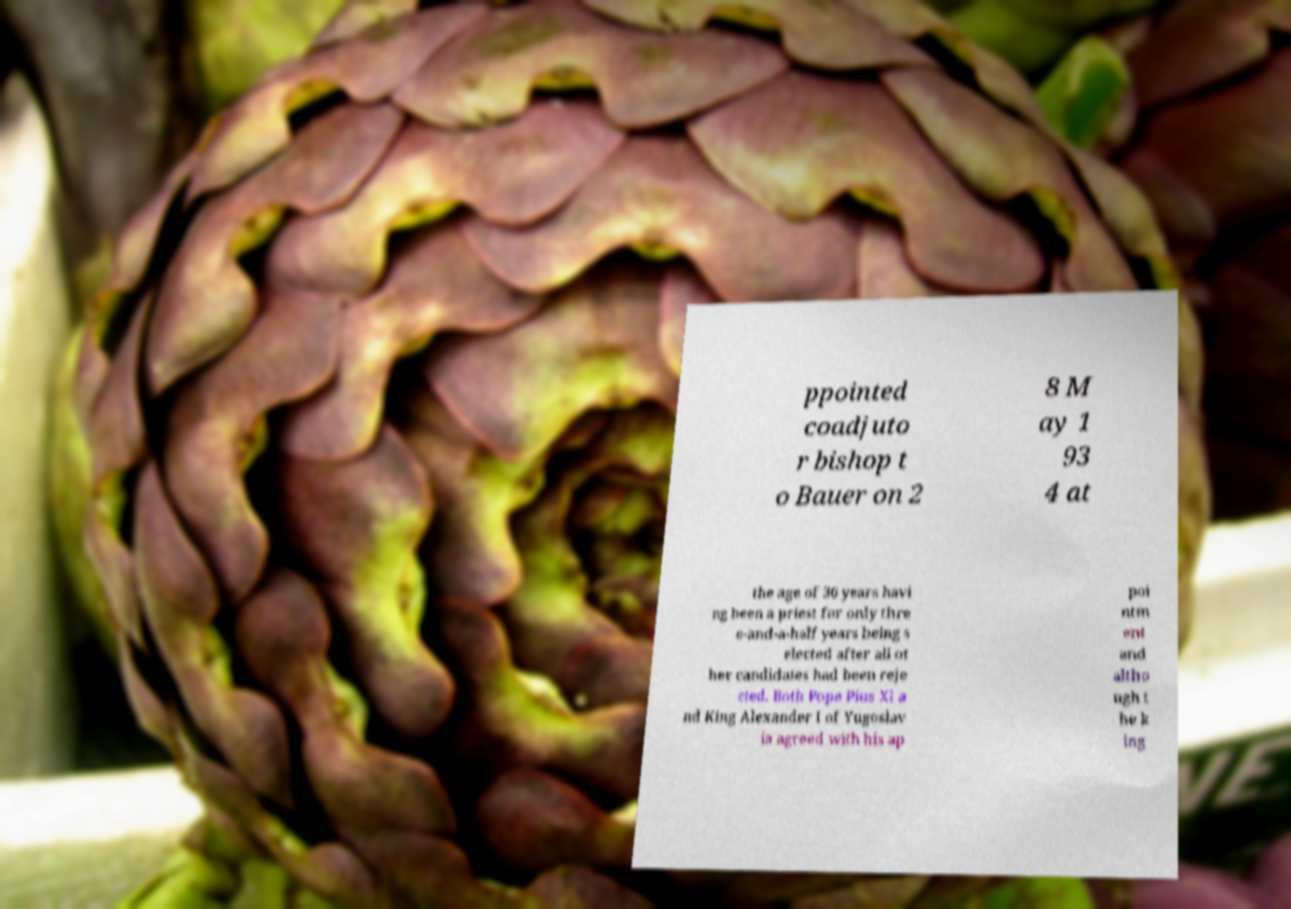Could you assist in decoding the text presented in this image and type it out clearly? ppointed coadjuto r bishop t o Bauer on 2 8 M ay 1 93 4 at the age of 36 years havi ng been a priest for only thre e-and-a-half years being s elected after all ot her candidates had been reje cted. Both Pope Pius XI a nd King Alexander I of Yugoslav ia agreed with his ap poi ntm ent and altho ugh t he k ing 